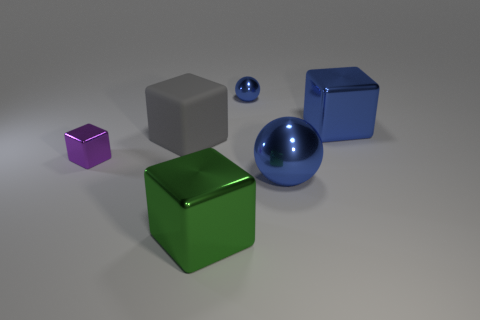Subtract all cyan cubes. Subtract all yellow cylinders. How many cubes are left? 4 Add 4 tiny rubber cylinders. How many objects exist? 10 Subtract all balls. How many objects are left? 4 Add 6 big blue objects. How many big blue objects exist? 8 Subtract 1 green blocks. How many objects are left? 5 Subtract all big green metal things. Subtract all small blue balls. How many objects are left? 4 Add 1 small spheres. How many small spheres are left? 2 